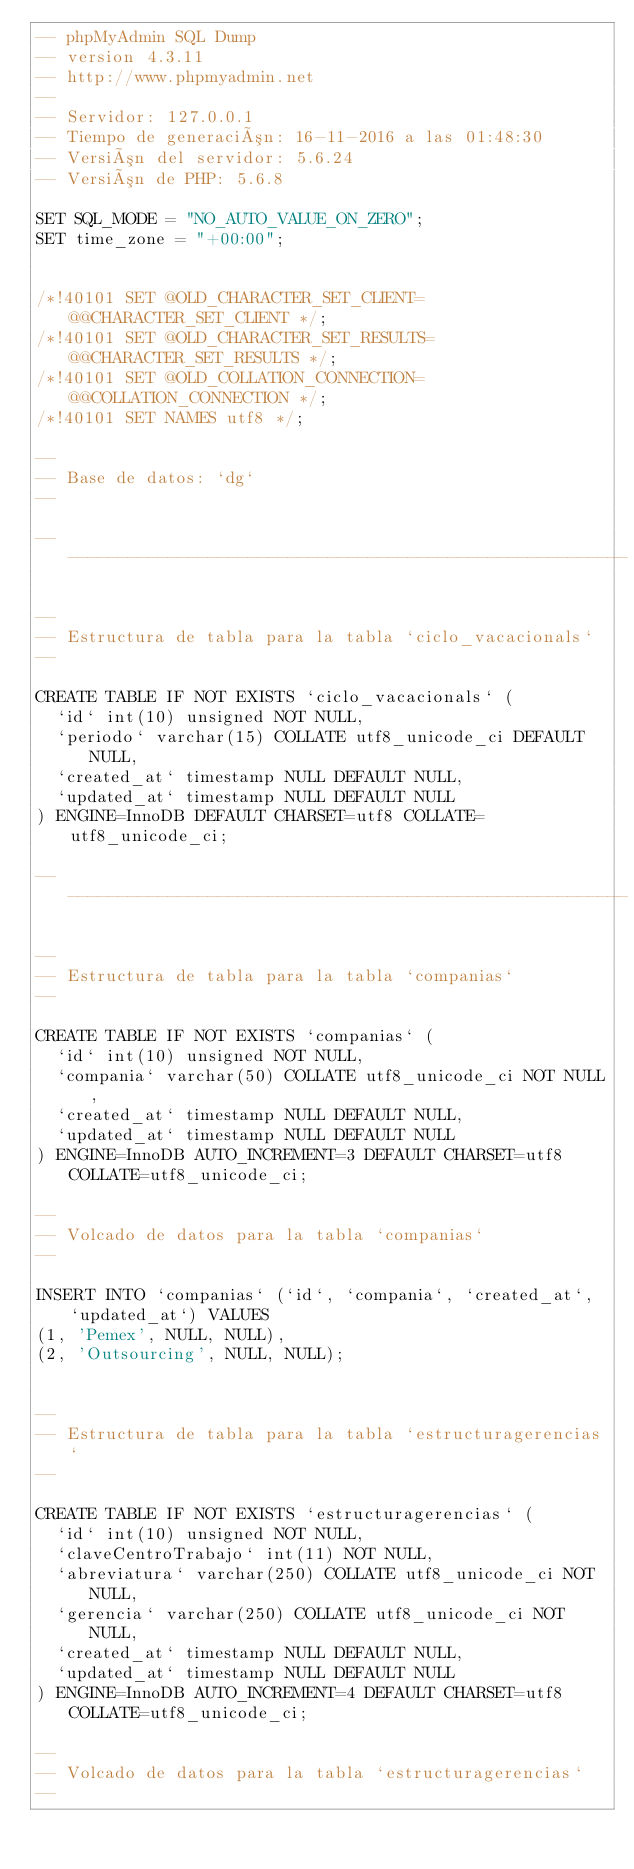<code> <loc_0><loc_0><loc_500><loc_500><_SQL_>-- phpMyAdmin SQL Dump
-- version 4.3.11
-- http://www.phpmyadmin.net
--
-- Servidor: 127.0.0.1
-- Tiempo de generación: 16-11-2016 a las 01:48:30
-- Versión del servidor: 5.6.24
-- Versión de PHP: 5.6.8

SET SQL_MODE = "NO_AUTO_VALUE_ON_ZERO";
SET time_zone = "+00:00";


/*!40101 SET @OLD_CHARACTER_SET_CLIENT=@@CHARACTER_SET_CLIENT */;
/*!40101 SET @OLD_CHARACTER_SET_RESULTS=@@CHARACTER_SET_RESULTS */;
/*!40101 SET @OLD_COLLATION_CONNECTION=@@COLLATION_CONNECTION */;
/*!40101 SET NAMES utf8 */;

--
-- Base de datos: `dg`
--

-- --------------------------------------------------------

--
-- Estructura de tabla para la tabla `ciclo_vacacionals`
--

CREATE TABLE IF NOT EXISTS `ciclo_vacacionals` (
  `id` int(10) unsigned NOT NULL,
  `periodo` varchar(15) COLLATE utf8_unicode_ci DEFAULT NULL,
  `created_at` timestamp NULL DEFAULT NULL,
  `updated_at` timestamp NULL DEFAULT NULL
) ENGINE=InnoDB DEFAULT CHARSET=utf8 COLLATE=utf8_unicode_ci;

-- --------------------------------------------------------

--
-- Estructura de tabla para la tabla `companias`
--

CREATE TABLE IF NOT EXISTS `companias` (
  `id` int(10) unsigned NOT NULL,
  `compania` varchar(50) COLLATE utf8_unicode_ci NOT NULL,
  `created_at` timestamp NULL DEFAULT NULL,
  `updated_at` timestamp NULL DEFAULT NULL
) ENGINE=InnoDB AUTO_INCREMENT=3 DEFAULT CHARSET=utf8 COLLATE=utf8_unicode_ci;

--
-- Volcado de datos para la tabla `companias`
--

INSERT INTO `companias` (`id`, `compania`, `created_at`, `updated_at`) VALUES
(1, 'Pemex', NULL, NULL),
(2, 'Outsourcing', NULL, NULL);


--
-- Estructura de tabla para la tabla `estructuragerencias`
--

CREATE TABLE IF NOT EXISTS `estructuragerencias` (
  `id` int(10) unsigned NOT NULL,
  `claveCentroTrabajo` int(11) NOT NULL,
  `abreviatura` varchar(250) COLLATE utf8_unicode_ci NOT NULL,
  `gerencia` varchar(250) COLLATE utf8_unicode_ci NOT NULL,
  `created_at` timestamp NULL DEFAULT NULL,
  `updated_at` timestamp NULL DEFAULT NULL
) ENGINE=InnoDB AUTO_INCREMENT=4 DEFAULT CHARSET=utf8 COLLATE=utf8_unicode_ci;

--
-- Volcado de datos para la tabla `estructuragerencias`
--
</code> 